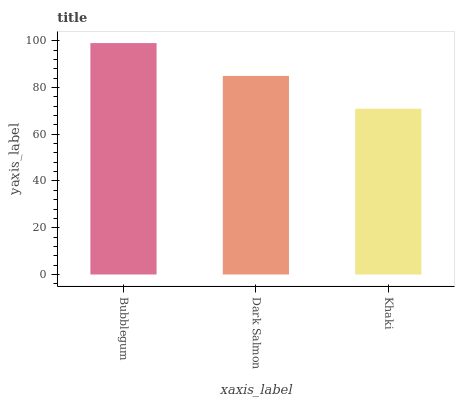Is Khaki the minimum?
Answer yes or no. Yes. Is Bubblegum the maximum?
Answer yes or no. Yes. Is Dark Salmon the minimum?
Answer yes or no. No. Is Dark Salmon the maximum?
Answer yes or no. No. Is Bubblegum greater than Dark Salmon?
Answer yes or no. Yes. Is Dark Salmon less than Bubblegum?
Answer yes or no. Yes. Is Dark Salmon greater than Bubblegum?
Answer yes or no. No. Is Bubblegum less than Dark Salmon?
Answer yes or no. No. Is Dark Salmon the high median?
Answer yes or no. Yes. Is Dark Salmon the low median?
Answer yes or no. Yes. Is Bubblegum the high median?
Answer yes or no. No. Is Bubblegum the low median?
Answer yes or no. No. 